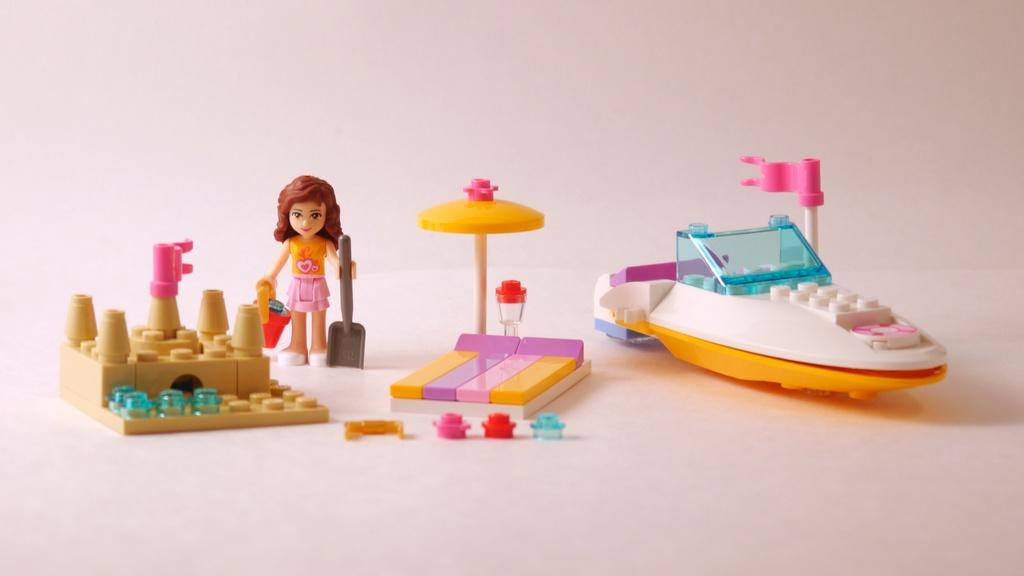What objects are present in the image? There are toys in the image. What color is the background of the image? The background of the image is white. What type of pump is visible in the image? There is no pump present in the image; it only contains toys. What flavor of jam can be seen on the toys in the image? There is no jam present in the image; it only contains toys. 